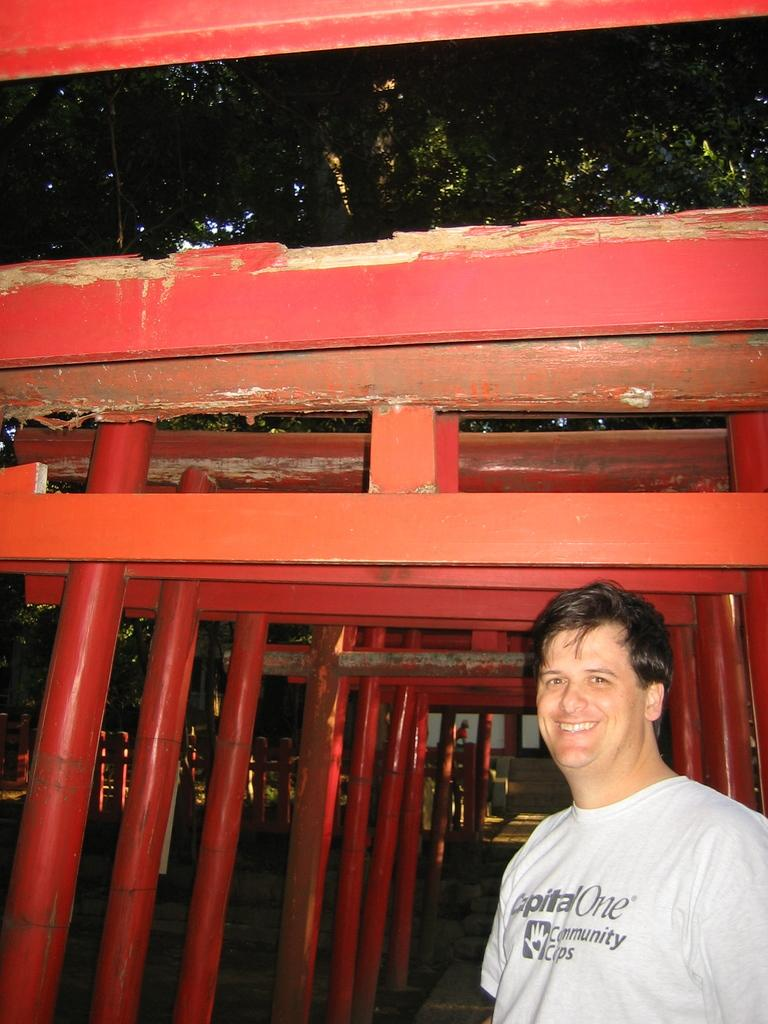Who is the main subject in the foreground of the image? There is a man in the foreground of the image. On which side of the image is the man located? The man is on the right side of the image. What can be seen in the background of the image? There are red pillars and beams, as well as trees, in the background of the image. How many questions being asked in the image? There is no indication in the image that more questions are being asked. Can you see a rat in the image? There is no rat present in the image. 